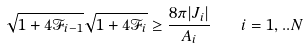Convert formula to latex. <formula><loc_0><loc_0><loc_500><loc_500>\sqrt { 1 + 4 \mathcal { F } _ { i - 1 } } \sqrt { 1 + 4 \mathcal { F } _ { i } } \geq \frac { 8 \pi | J _ { i } | } { A _ { i } } \quad i = 1 , . . N</formula> 